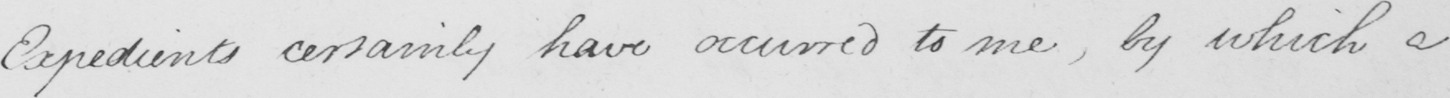Can you tell me what this handwritten text says? Expedients certainly have occurred to me , by which a 